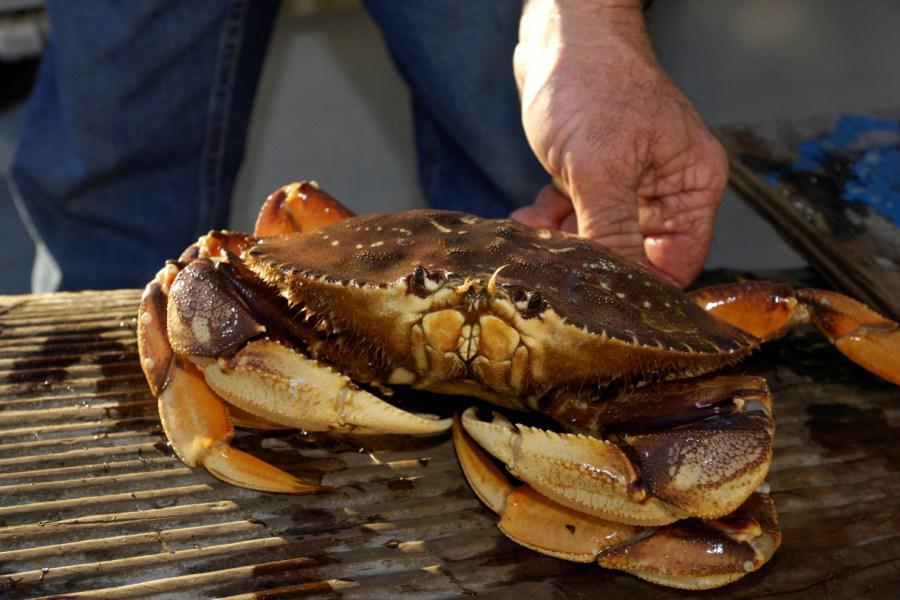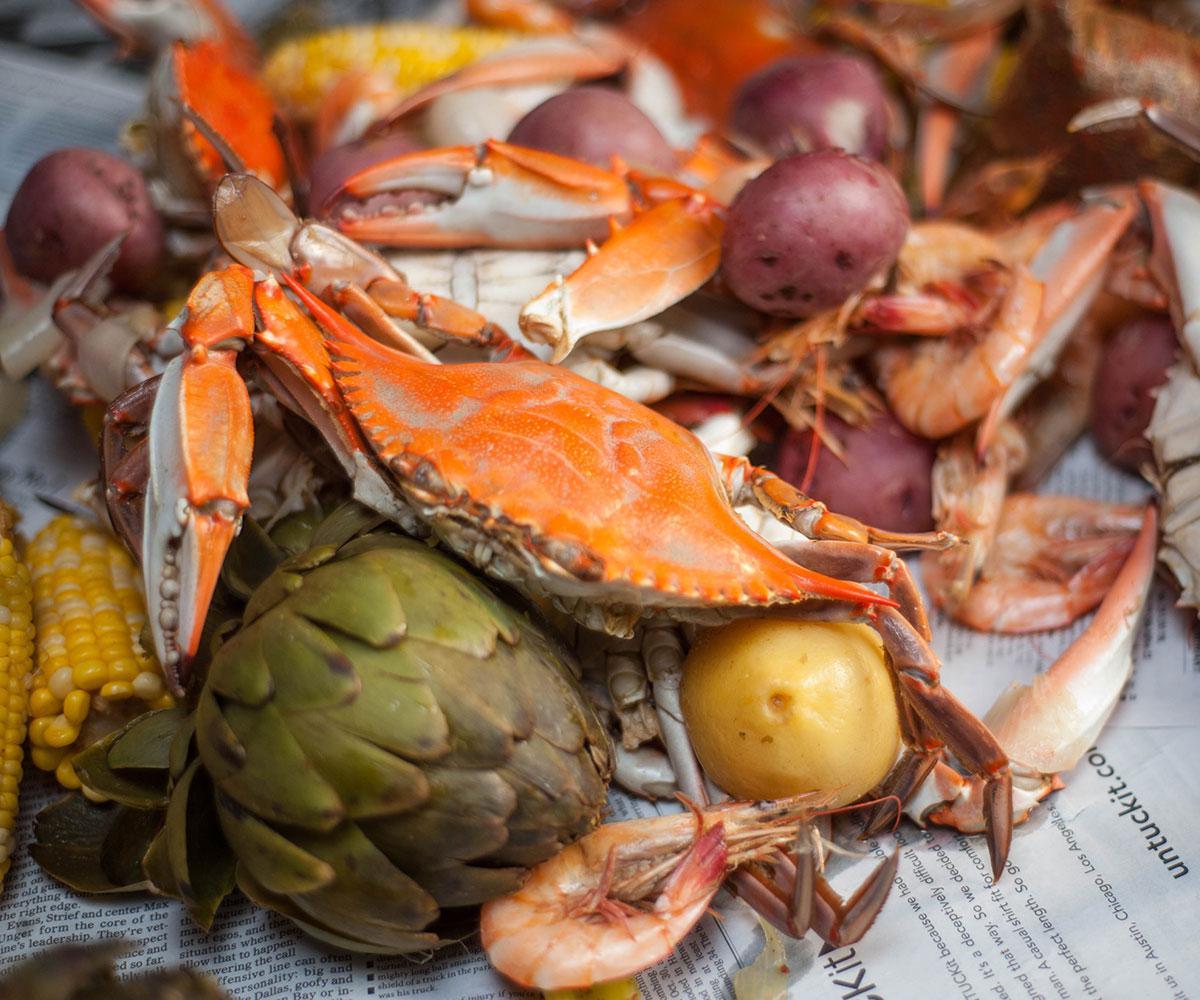The first image is the image on the left, the second image is the image on the right. Evaluate the accuracy of this statement regarding the images: "The image on the right shows red crabs on top of vegetables including corn.". Is it true? Answer yes or no. Yes. The first image is the image on the left, the second image is the image on the right. Assess this claim about the two images: "In one image, a person's hand can be seen holding a single large crab with its legs curled in front.". Correct or not? Answer yes or no. Yes. 